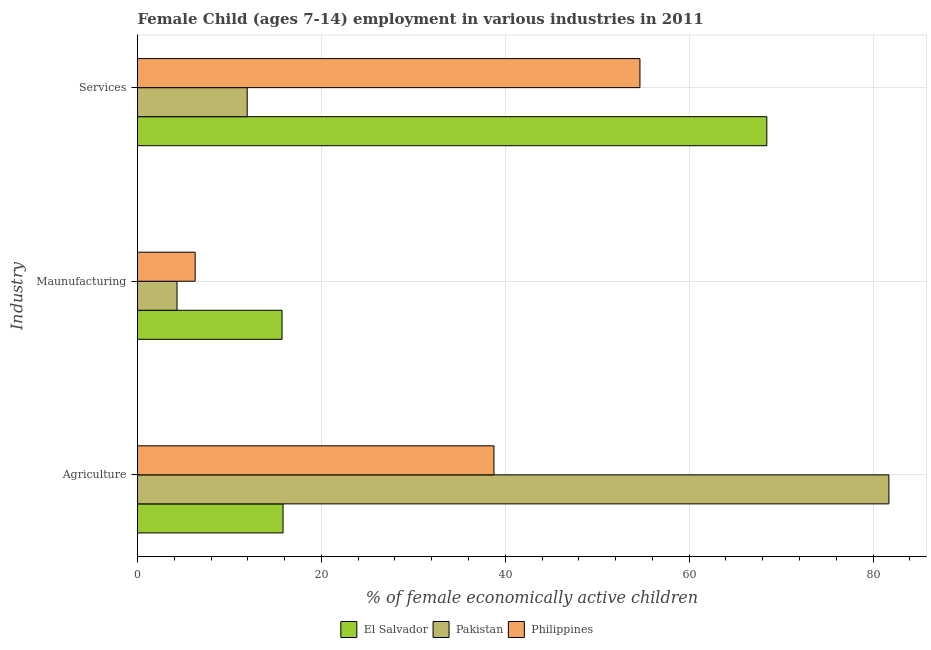How many different coloured bars are there?
Keep it short and to the point. 3. How many groups of bars are there?
Your answer should be very brief. 3. Are the number of bars per tick equal to the number of legend labels?
Make the answer very short. Yes. Are the number of bars on each tick of the Y-axis equal?
Ensure brevity in your answer.  Yes. How many bars are there on the 1st tick from the top?
Provide a succinct answer. 3. How many bars are there on the 2nd tick from the bottom?
Your answer should be very brief. 3. What is the label of the 1st group of bars from the top?
Provide a succinct answer. Services. What is the percentage of economically active children in agriculture in El Salvador?
Make the answer very short. 15.83. Across all countries, what is the maximum percentage of economically active children in agriculture?
Offer a terse response. 81.73. Across all countries, what is the minimum percentage of economically active children in services?
Provide a short and direct response. 11.93. In which country was the percentage of economically active children in manufacturing minimum?
Your answer should be compact. Pakistan. What is the total percentage of economically active children in services in the graph?
Offer a very short reply. 135.03. What is the difference between the percentage of economically active children in agriculture in El Salvador and that in Pakistan?
Make the answer very short. -65.9. What is the difference between the percentage of economically active children in agriculture in Philippines and the percentage of economically active children in manufacturing in El Salvador?
Provide a succinct answer. 23.05. What is the average percentage of economically active children in manufacturing per country?
Give a very brief answer. 8.76. What is the difference between the percentage of economically active children in agriculture and percentage of economically active children in services in Pakistan?
Ensure brevity in your answer.  69.8. In how many countries, is the percentage of economically active children in agriculture greater than 32 %?
Your response must be concise. 2. What is the ratio of the percentage of economically active children in agriculture in Philippines to that in El Salvador?
Provide a succinct answer. 2.45. Is the difference between the percentage of economically active children in services in Pakistan and El Salvador greater than the difference between the percentage of economically active children in manufacturing in Pakistan and El Salvador?
Offer a very short reply. No. What is the difference between the highest and the second highest percentage of economically active children in agriculture?
Keep it short and to the point. 42.96. What is the difference between the highest and the lowest percentage of economically active children in agriculture?
Provide a short and direct response. 65.9. How many countries are there in the graph?
Provide a short and direct response. 3. What is the difference between two consecutive major ticks on the X-axis?
Provide a short and direct response. 20. Are the values on the major ticks of X-axis written in scientific E-notation?
Offer a very short reply. No. Does the graph contain any zero values?
Offer a terse response. No. Does the graph contain grids?
Ensure brevity in your answer.  Yes. Where does the legend appear in the graph?
Your answer should be very brief. Bottom center. How are the legend labels stacked?
Your response must be concise. Horizontal. What is the title of the graph?
Make the answer very short. Female Child (ages 7-14) employment in various industries in 2011. Does "Rwanda" appear as one of the legend labels in the graph?
Offer a very short reply. No. What is the label or title of the X-axis?
Ensure brevity in your answer.  % of female economically active children. What is the label or title of the Y-axis?
Your answer should be very brief. Industry. What is the % of female economically active children in El Salvador in Agriculture?
Your response must be concise. 15.83. What is the % of female economically active children of Pakistan in Agriculture?
Provide a short and direct response. 81.73. What is the % of female economically active children of Philippines in Agriculture?
Provide a short and direct response. 38.77. What is the % of female economically active children of El Salvador in Maunufacturing?
Your answer should be compact. 15.72. What is the % of female economically active children of Philippines in Maunufacturing?
Provide a short and direct response. 6.27. What is the % of female economically active children of El Salvador in Services?
Provide a succinct answer. 68.45. What is the % of female economically active children of Pakistan in Services?
Provide a succinct answer. 11.93. What is the % of female economically active children of Philippines in Services?
Offer a terse response. 54.65. Across all Industry, what is the maximum % of female economically active children in El Salvador?
Make the answer very short. 68.45. Across all Industry, what is the maximum % of female economically active children of Pakistan?
Make the answer very short. 81.73. Across all Industry, what is the maximum % of female economically active children in Philippines?
Provide a succinct answer. 54.65. Across all Industry, what is the minimum % of female economically active children of El Salvador?
Keep it short and to the point. 15.72. Across all Industry, what is the minimum % of female economically active children of Pakistan?
Keep it short and to the point. 4.3. Across all Industry, what is the minimum % of female economically active children in Philippines?
Offer a very short reply. 6.27. What is the total % of female economically active children in El Salvador in the graph?
Ensure brevity in your answer.  100. What is the total % of female economically active children in Pakistan in the graph?
Offer a very short reply. 97.96. What is the total % of female economically active children in Philippines in the graph?
Your answer should be compact. 99.69. What is the difference between the % of female economically active children of El Salvador in Agriculture and that in Maunufacturing?
Your answer should be compact. 0.11. What is the difference between the % of female economically active children of Pakistan in Agriculture and that in Maunufacturing?
Provide a succinct answer. 77.43. What is the difference between the % of female economically active children of Philippines in Agriculture and that in Maunufacturing?
Provide a short and direct response. 32.5. What is the difference between the % of female economically active children of El Salvador in Agriculture and that in Services?
Keep it short and to the point. -52.62. What is the difference between the % of female economically active children of Pakistan in Agriculture and that in Services?
Keep it short and to the point. 69.8. What is the difference between the % of female economically active children of Philippines in Agriculture and that in Services?
Your answer should be very brief. -15.88. What is the difference between the % of female economically active children of El Salvador in Maunufacturing and that in Services?
Provide a short and direct response. -52.73. What is the difference between the % of female economically active children of Pakistan in Maunufacturing and that in Services?
Your answer should be very brief. -7.63. What is the difference between the % of female economically active children of Philippines in Maunufacturing and that in Services?
Make the answer very short. -48.38. What is the difference between the % of female economically active children of El Salvador in Agriculture and the % of female economically active children of Pakistan in Maunufacturing?
Provide a succinct answer. 11.53. What is the difference between the % of female economically active children of El Salvador in Agriculture and the % of female economically active children of Philippines in Maunufacturing?
Your response must be concise. 9.56. What is the difference between the % of female economically active children in Pakistan in Agriculture and the % of female economically active children in Philippines in Maunufacturing?
Your answer should be compact. 75.46. What is the difference between the % of female economically active children of El Salvador in Agriculture and the % of female economically active children of Philippines in Services?
Ensure brevity in your answer.  -38.82. What is the difference between the % of female economically active children in Pakistan in Agriculture and the % of female economically active children in Philippines in Services?
Your answer should be very brief. 27.08. What is the difference between the % of female economically active children of El Salvador in Maunufacturing and the % of female economically active children of Pakistan in Services?
Provide a succinct answer. 3.79. What is the difference between the % of female economically active children in El Salvador in Maunufacturing and the % of female economically active children in Philippines in Services?
Your response must be concise. -38.93. What is the difference between the % of female economically active children of Pakistan in Maunufacturing and the % of female economically active children of Philippines in Services?
Offer a terse response. -50.35. What is the average % of female economically active children in El Salvador per Industry?
Keep it short and to the point. 33.33. What is the average % of female economically active children in Pakistan per Industry?
Your answer should be very brief. 32.65. What is the average % of female economically active children in Philippines per Industry?
Provide a short and direct response. 33.23. What is the difference between the % of female economically active children in El Salvador and % of female economically active children in Pakistan in Agriculture?
Keep it short and to the point. -65.9. What is the difference between the % of female economically active children of El Salvador and % of female economically active children of Philippines in Agriculture?
Provide a short and direct response. -22.94. What is the difference between the % of female economically active children in Pakistan and % of female economically active children in Philippines in Agriculture?
Keep it short and to the point. 42.96. What is the difference between the % of female economically active children of El Salvador and % of female economically active children of Pakistan in Maunufacturing?
Ensure brevity in your answer.  11.42. What is the difference between the % of female economically active children in El Salvador and % of female economically active children in Philippines in Maunufacturing?
Your answer should be compact. 9.45. What is the difference between the % of female economically active children of Pakistan and % of female economically active children of Philippines in Maunufacturing?
Offer a very short reply. -1.97. What is the difference between the % of female economically active children in El Salvador and % of female economically active children in Pakistan in Services?
Give a very brief answer. 56.52. What is the difference between the % of female economically active children of El Salvador and % of female economically active children of Philippines in Services?
Your response must be concise. 13.8. What is the difference between the % of female economically active children of Pakistan and % of female economically active children of Philippines in Services?
Make the answer very short. -42.72. What is the ratio of the % of female economically active children of Pakistan in Agriculture to that in Maunufacturing?
Provide a succinct answer. 19.01. What is the ratio of the % of female economically active children of Philippines in Agriculture to that in Maunufacturing?
Ensure brevity in your answer.  6.18. What is the ratio of the % of female economically active children of El Salvador in Agriculture to that in Services?
Your answer should be compact. 0.23. What is the ratio of the % of female economically active children in Pakistan in Agriculture to that in Services?
Give a very brief answer. 6.85. What is the ratio of the % of female economically active children in Philippines in Agriculture to that in Services?
Give a very brief answer. 0.71. What is the ratio of the % of female economically active children of El Salvador in Maunufacturing to that in Services?
Your answer should be very brief. 0.23. What is the ratio of the % of female economically active children in Pakistan in Maunufacturing to that in Services?
Your response must be concise. 0.36. What is the ratio of the % of female economically active children of Philippines in Maunufacturing to that in Services?
Offer a very short reply. 0.11. What is the difference between the highest and the second highest % of female economically active children in El Salvador?
Your answer should be compact. 52.62. What is the difference between the highest and the second highest % of female economically active children in Pakistan?
Ensure brevity in your answer.  69.8. What is the difference between the highest and the second highest % of female economically active children in Philippines?
Provide a short and direct response. 15.88. What is the difference between the highest and the lowest % of female economically active children in El Salvador?
Keep it short and to the point. 52.73. What is the difference between the highest and the lowest % of female economically active children of Pakistan?
Make the answer very short. 77.43. What is the difference between the highest and the lowest % of female economically active children in Philippines?
Provide a succinct answer. 48.38. 